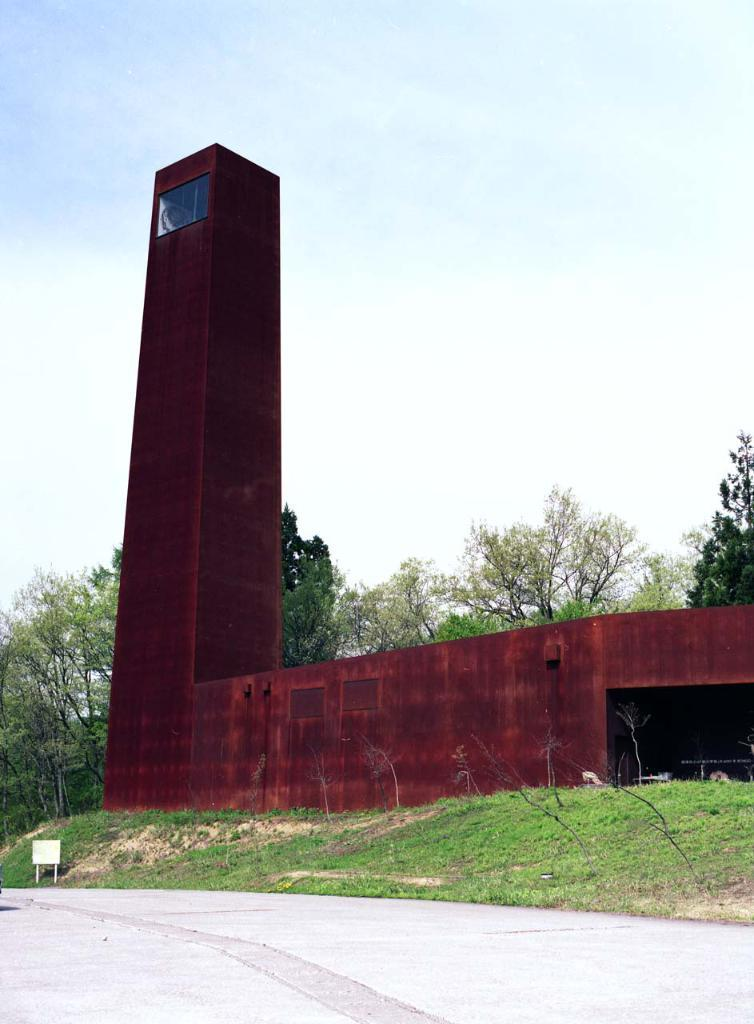What is the main object in the image? There is a white board in the image. What is the color of the building in the image? The building in the image is red-colored. What type of natural vegetation can be seen in the image? There are trees visible in the image. What is visible in the background of the image? The sky is visible in the background of the image. What type of corn is being grown near the red-colored building in the image? There is no corn visible in the image; it only features a white board, a red-colored building, trees, and the sky. What flavor of ice cream is being served on the white board in the image? There is no ice cream or any food item present on the white board in the image. 